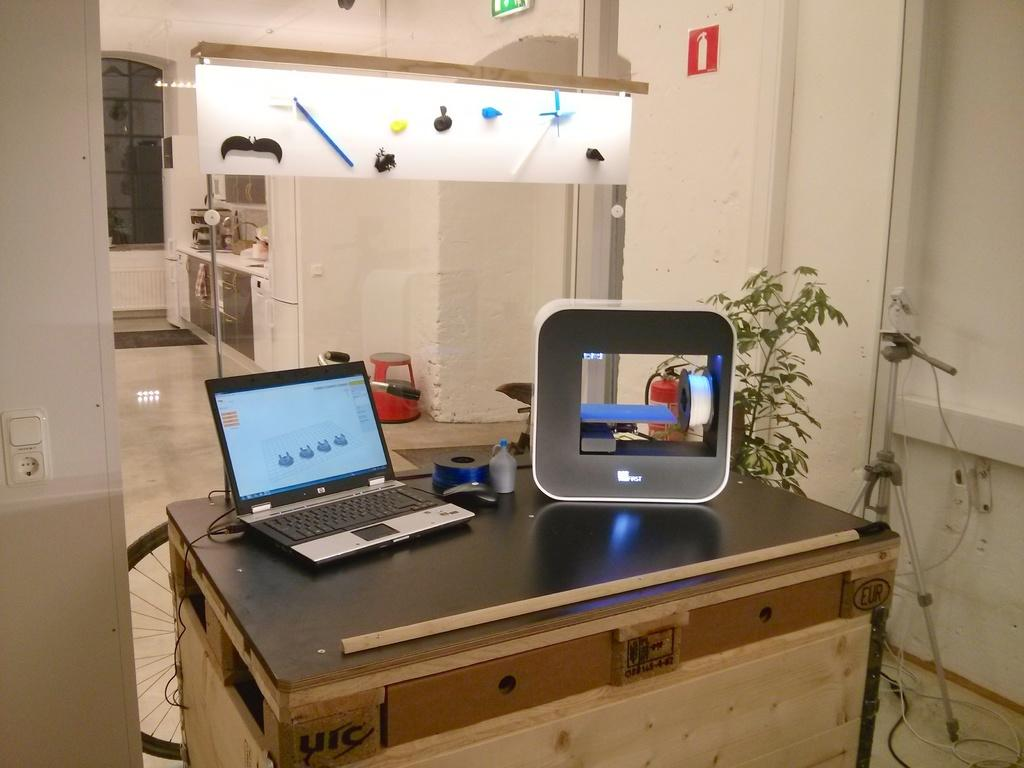What piece of furniture can be seen in the image? There is a table in the image. What electronic device is on the table? A laptop is present on the table. What else is on the table besides the laptop? There are other objects on the table. Can you describe the plant in the image? There is a white plant in the image. What color is the wall in the image? There is a white wall in the image. What type of texture can be felt on the celery in the image? There is no celery present in the image, so it is not possible to determine its texture. 